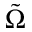<formula> <loc_0><loc_0><loc_500><loc_500>\tilde { \Omega }</formula> 